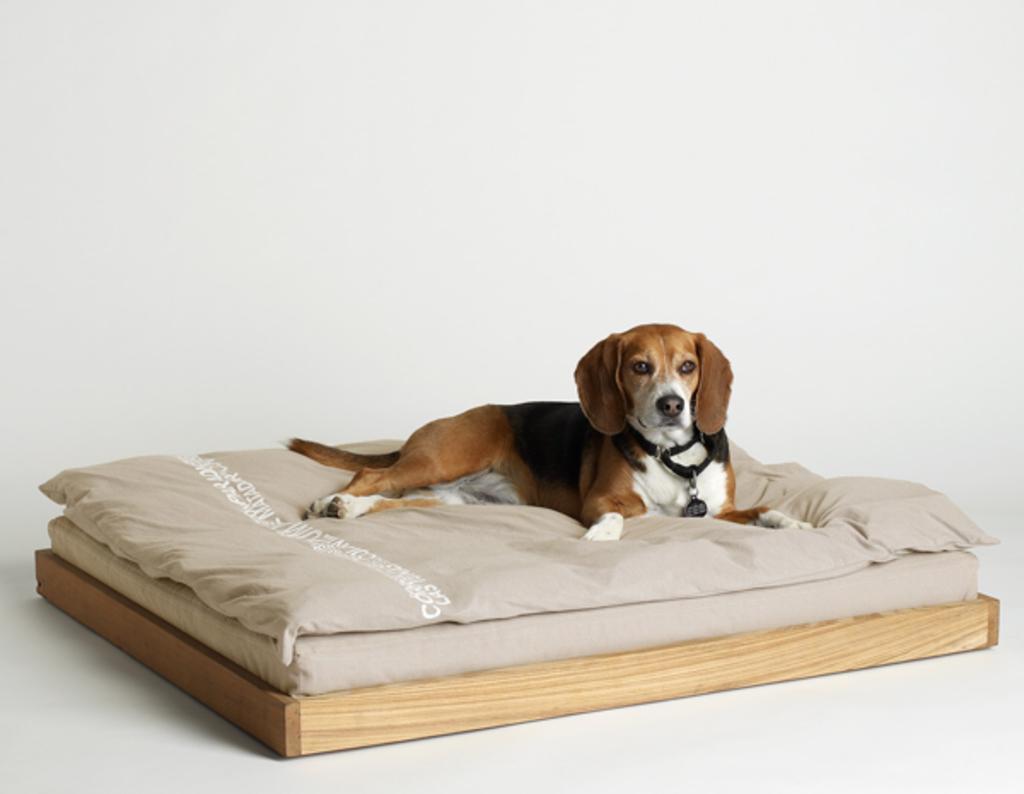How would you summarize this image in a sentence or two? In this image I can see a dog is laying on the bed. Under the bed there is a wooden plank. The background is in white color. 